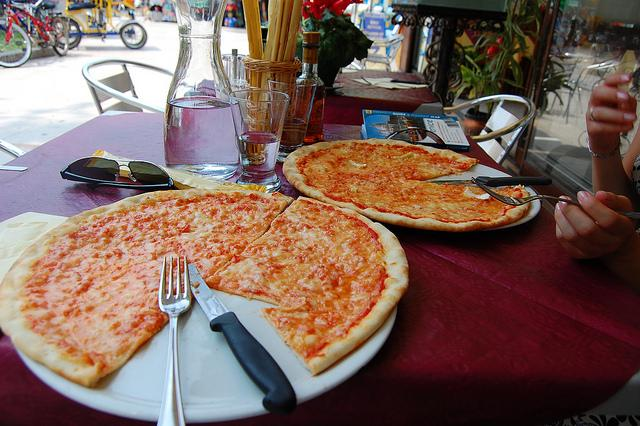What color is the vase in the middle of the table surrounded by pizzas?

Choices:
A) black
B) red
C) clear
D) white clear 